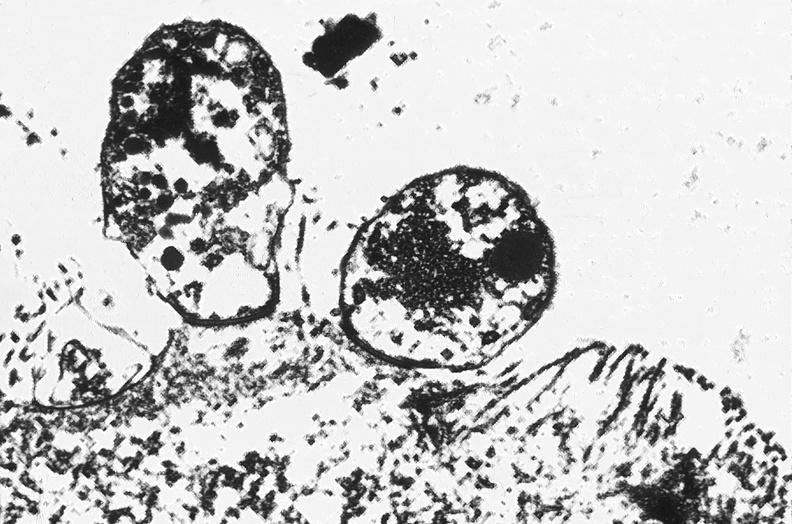s gastrointestinal present?
Answer the question using a single word or phrase. Yes 